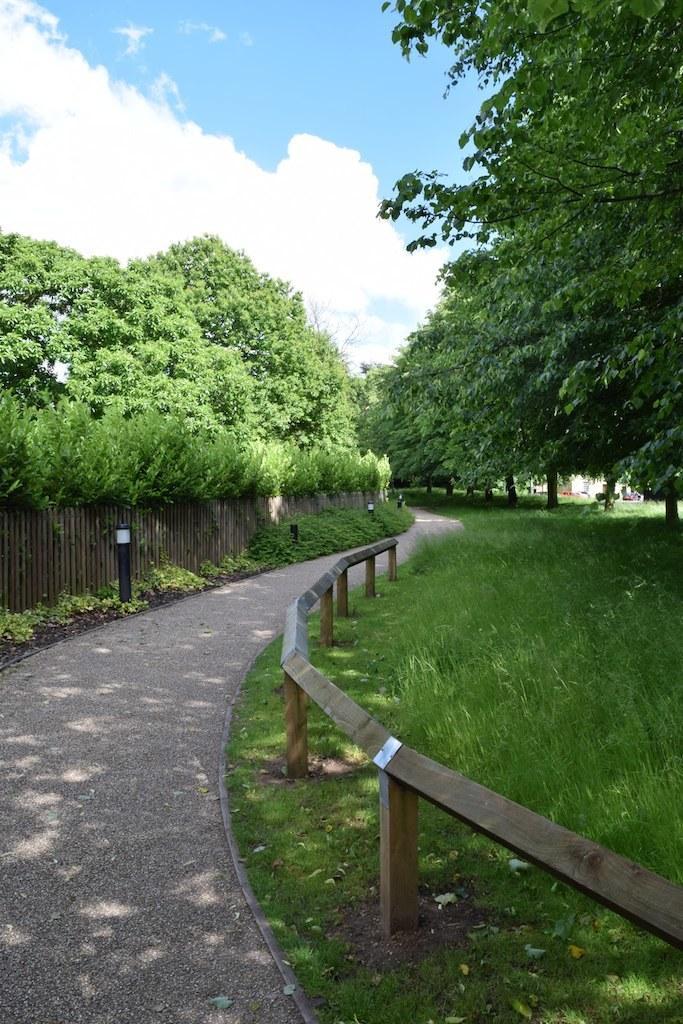In one or two sentences, can you explain what this image depicts? In this image, we can see the ground. We can see some grass, plants and trees. We can also see the fence and some poles. We can also see the sky with clouds. 